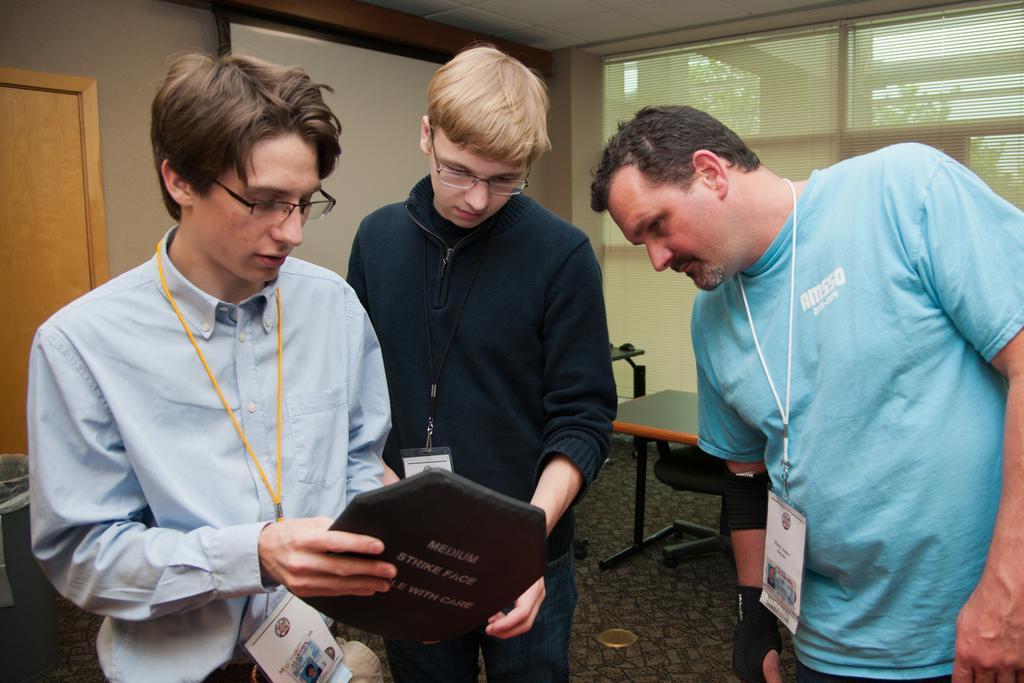In one or two sentences, can you explain what this image depicts? In this picture there is a person in left corner is standing and holding an object in his hand and there are two persons standing beside them and looking in to the object and there is a projector,table and a glass window in the background. 